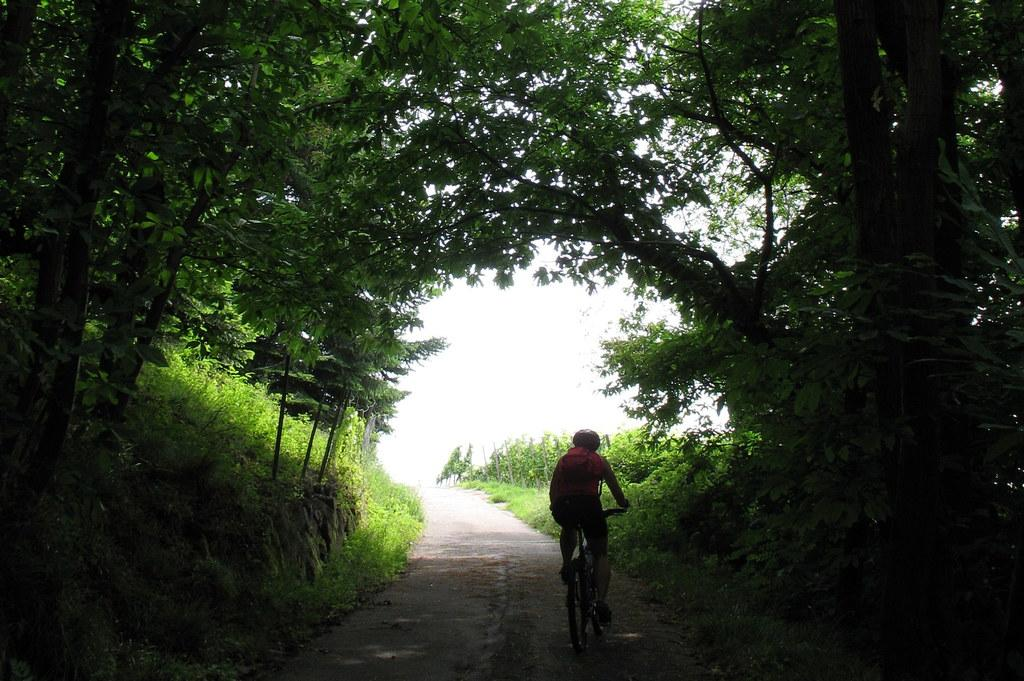What is the person in the image doing? The person is riding a bicycle on the road. What type of vegetation can be seen in the image? There is grass, plants, and trees visible in the image. What is visible in the background of the image? The sky is visible in the background of the image. What type of plate is being used to shade the person riding the bicycle in the image? There is no plate present in the image, and the person riding the bicycle is not being shaded by any object. 